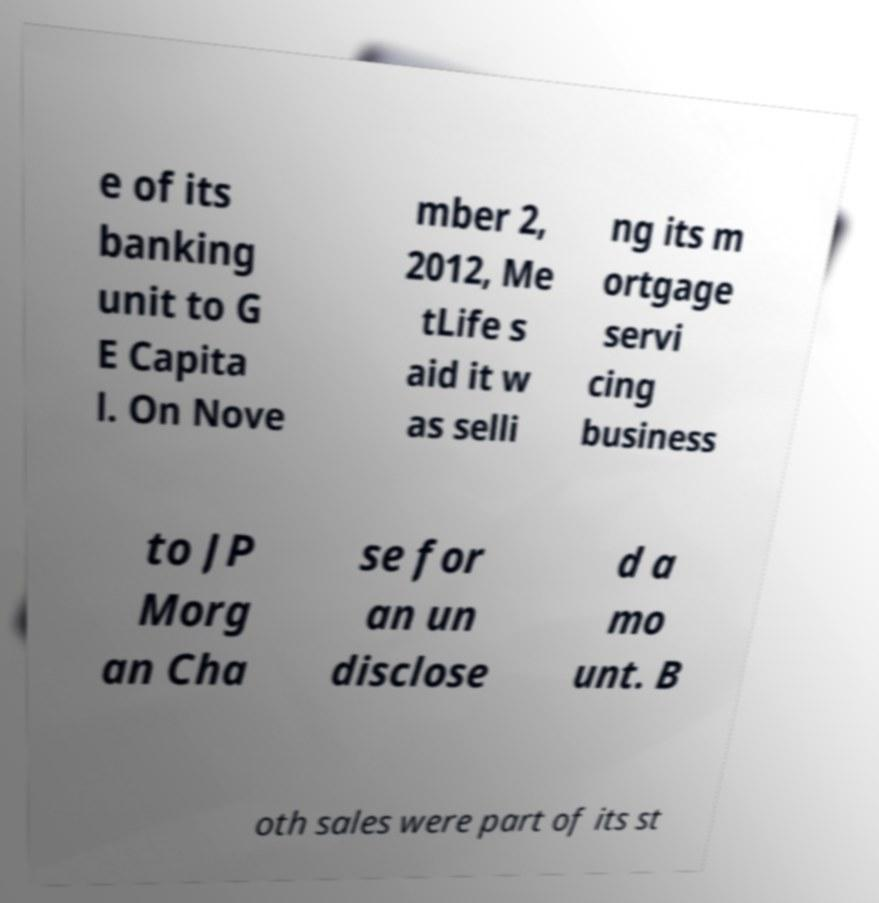Please read and relay the text visible in this image. What does it say? e of its banking unit to G E Capita l. On Nove mber 2, 2012, Me tLife s aid it w as selli ng its m ortgage servi cing business to JP Morg an Cha se for an un disclose d a mo unt. B oth sales were part of its st 